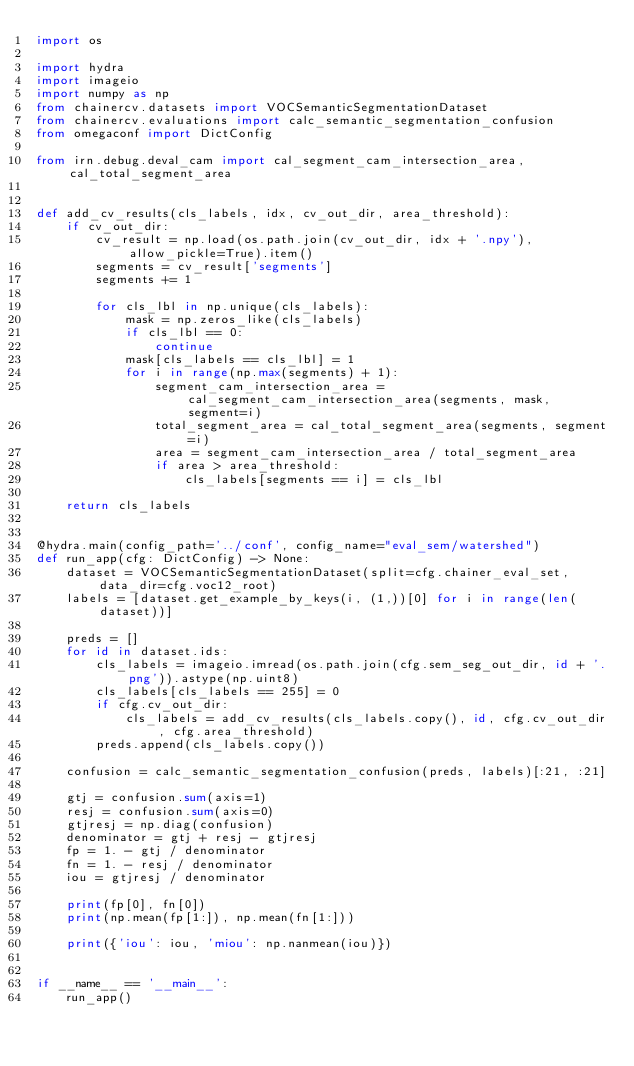<code> <loc_0><loc_0><loc_500><loc_500><_Python_>import os

import hydra
import imageio
import numpy as np
from chainercv.datasets import VOCSemanticSegmentationDataset
from chainercv.evaluations import calc_semantic_segmentation_confusion
from omegaconf import DictConfig

from irn.debug.deval_cam import cal_segment_cam_intersection_area, cal_total_segment_area


def add_cv_results(cls_labels, idx, cv_out_dir, area_threshold):
    if cv_out_dir:
        cv_result = np.load(os.path.join(cv_out_dir, idx + '.npy'), allow_pickle=True).item()
        segments = cv_result['segments']
        segments += 1

        for cls_lbl in np.unique(cls_labels):
            mask = np.zeros_like(cls_labels)
            if cls_lbl == 0:
                continue
            mask[cls_labels == cls_lbl] = 1
            for i in range(np.max(segments) + 1):
                segment_cam_intersection_area = cal_segment_cam_intersection_area(segments, mask, segment=i)
                total_segment_area = cal_total_segment_area(segments, segment=i)
                area = segment_cam_intersection_area / total_segment_area
                if area > area_threshold:
                    cls_labels[segments == i] = cls_lbl

    return cls_labels


@hydra.main(config_path='../conf', config_name="eval_sem/watershed")
def run_app(cfg: DictConfig) -> None:
    dataset = VOCSemanticSegmentationDataset(split=cfg.chainer_eval_set, data_dir=cfg.voc12_root)
    labels = [dataset.get_example_by_keys(i, (1,))[0] for i in range(len(dataset))]

    preds = []
    for id in dataset.ids:
        cls_labels = imageio.imread(os.path.join(cfg.sem_seg_out_dir, id + '.png')).astype(np.uint8)
        cls_labels[cls_labels == 255] = 0
        if cfg.cv_out_dir:
            cls_labels = add_cv_results(cls_labels.copy(), id, cfg.cv_out_dir, cfg.area_threshold)
        preds.append(cls_labels.copy())

    confusion = calc_semantic_segmentation_confusion(preds, labels)[:21, :21]

    gtj = confusion.sum(axis=1)
    resj = confusion.sum(axis=0)
    gtjresj = np.diag(confusion)
    denominator = gtj + resj - gtjresj
    fp = 1. - gtj / denominator
    fn = 1. - resj / denominator
    iou = gtjresj / denominator

    print(fp[0], fn[0])
    print(np.mean(fp[1:]), np.mean(fn[1:]))

    print({'iou': iou, 'miou': np.nanmean(iou)})


if __name__ == '__main__':
    run_app()
</code> 